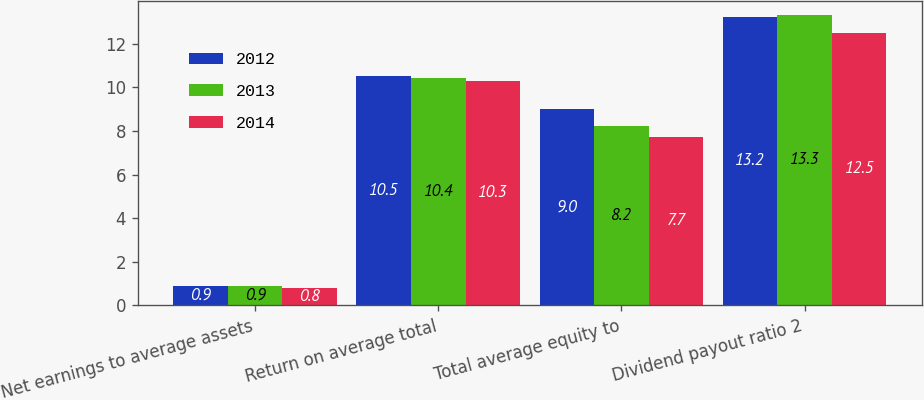<chart> <loc_0><loc_0><loc_500><loc_500><stacked_bar_chart><ecel><fcel>Net earnings to average assets<fcel>Return on average total<fcel>Total average equity to<fcel>Dividend payout ratio 2<nl><fcel>2012<fcel>0.9<fcel>10.5<fcel>9<fcel>13.2<nl><fcel>2013<fcel>0.9<fcel>10.4<fcel>8.2<fcel>13.3<nl><fcel>2014<fcel>0.8<fcel>10.3<fcel>7.7<fcel>12.5<nl></chart> 